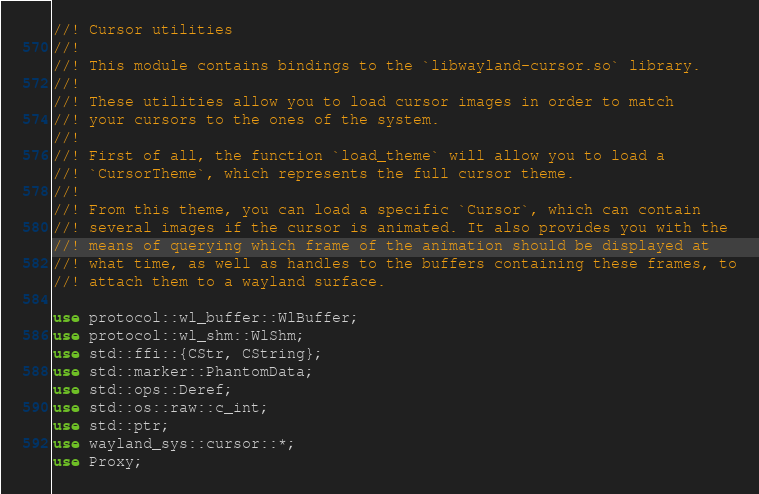Convert code to text. <code><loc_0><loc_0><loc_500><loc_500><_Rust_>//! Cursor utilities
//!
//! This module contains bindings to the `libwayland-cursor.so` library.
//!
//! These utilities allow you to load cursor images in order to match
//! your cursors to the ones of the system.
//!
//! First of all, the function `load_theme` will allow you to load a
//! `CursorTheme`, which represents the full cursor theme.
//!
//! From this theme, you can load a specific `Cursor`, which can contain
//! several images if the cursor is animated. It also provides you with the
//! means of querying which frame of the animation should be displayed at
//! what time, as well as handles to the buffers containing these frames, to
//! attach them to a wayland surface.

use protocol::wl_buffer::WlBuffer;
use protocol::wl_shm::WlShm;
use std::ffi::{CStr, CString};
use std::marker::PhantomData;
use std::ops::Deref;
use std::os::raw::c_int;
use std::ptr;
use wayland_sys::cursor::*;
use Proxy;
</code> 